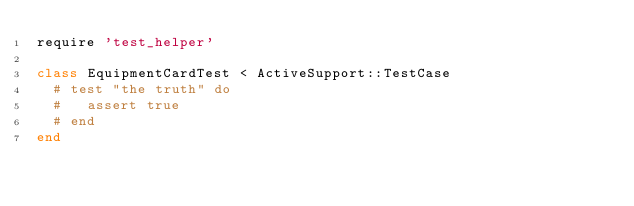Convert code to text. <code><loc_0><loc_0><loc_500><loc_500><_Ruby_>require 'test_helper'

class EquipmentCardTest < ActiveSupport::TestCase
  # test "the truth" do
  #   assert true
  # end
end
</code> 